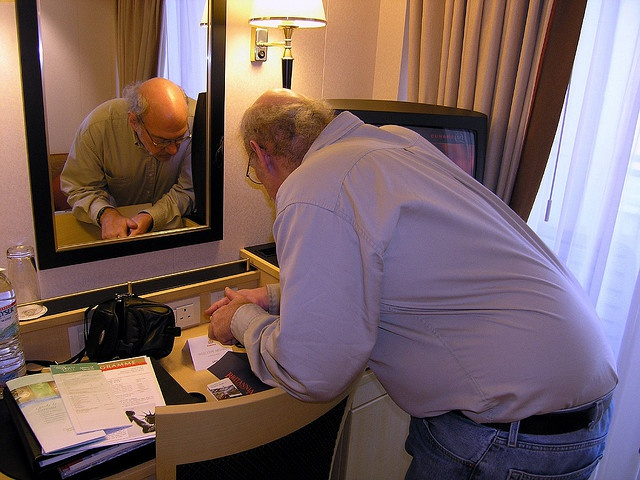Describe the objects in this image and their specific colors. I can see people in orange, purple, and gray tones, people in orange, maroon, black, and brown tones, chair in orange, maroon, black, and tan tones, tv in orange, black, maroon, and purple tones, and book in orange, tan, and olive tones in this image. 